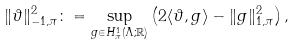<formula> <loc_0><loc_0><loc_500><loc_500>\| \vartheta \| _ { - 1 , \pi } ^ { 2 } \colon = \sup _ { g \in H _ { \pi } ^ { 1 } ( \Lambda ; \mathbb { R } ) } \left ( 2 \langle \vartheta , g \rangle - \| g \| _ { 1 , \pi } ^ { 2 } \right ) ,</formula> 